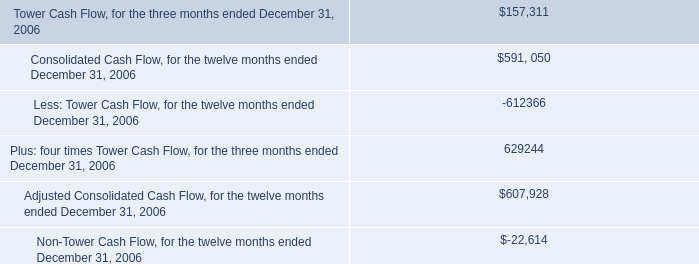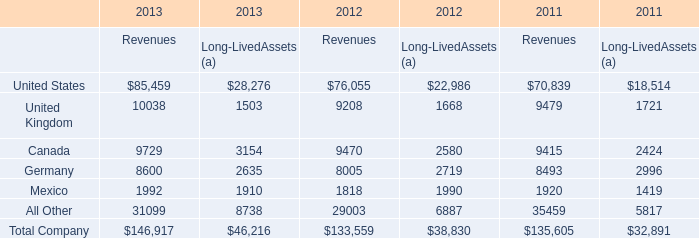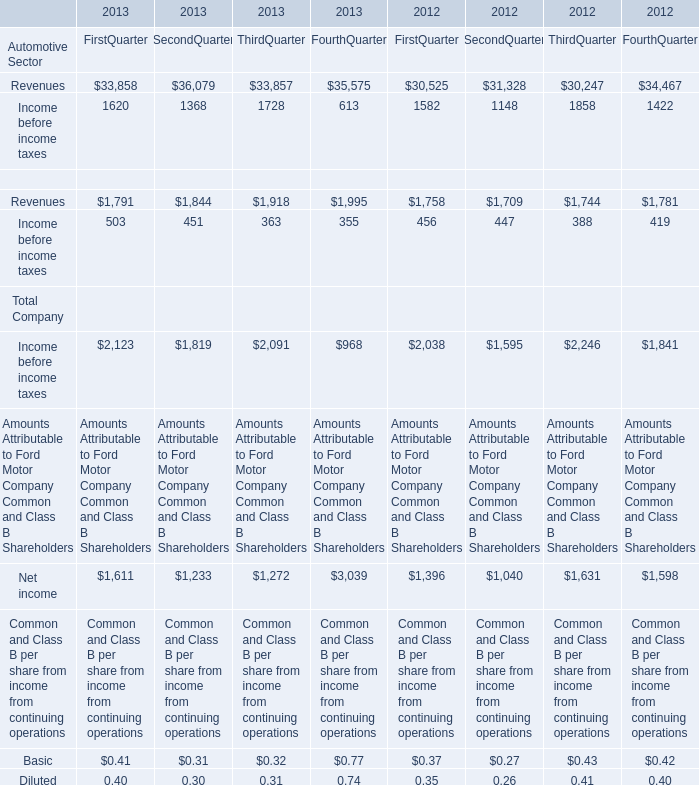Which year is United kingdom of revenues the highest? 
Answer: 2013. 